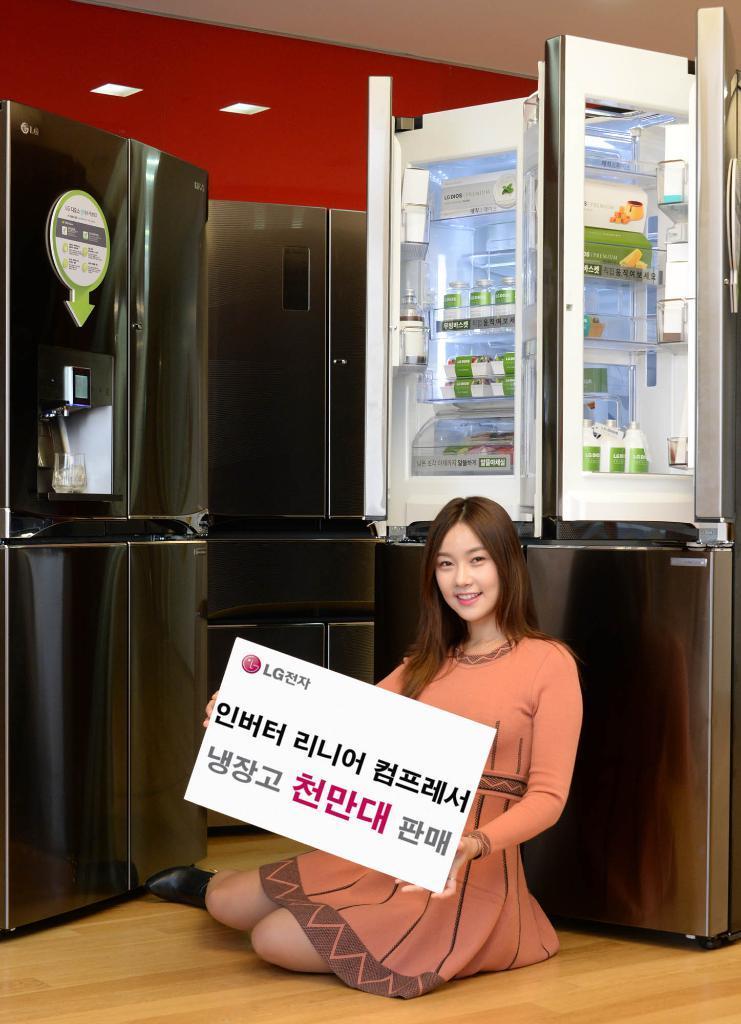In one or two sentences, can you explain what this image depicts? As we can see in the image there is a wall, refrigerators and a woman holding a banner. 